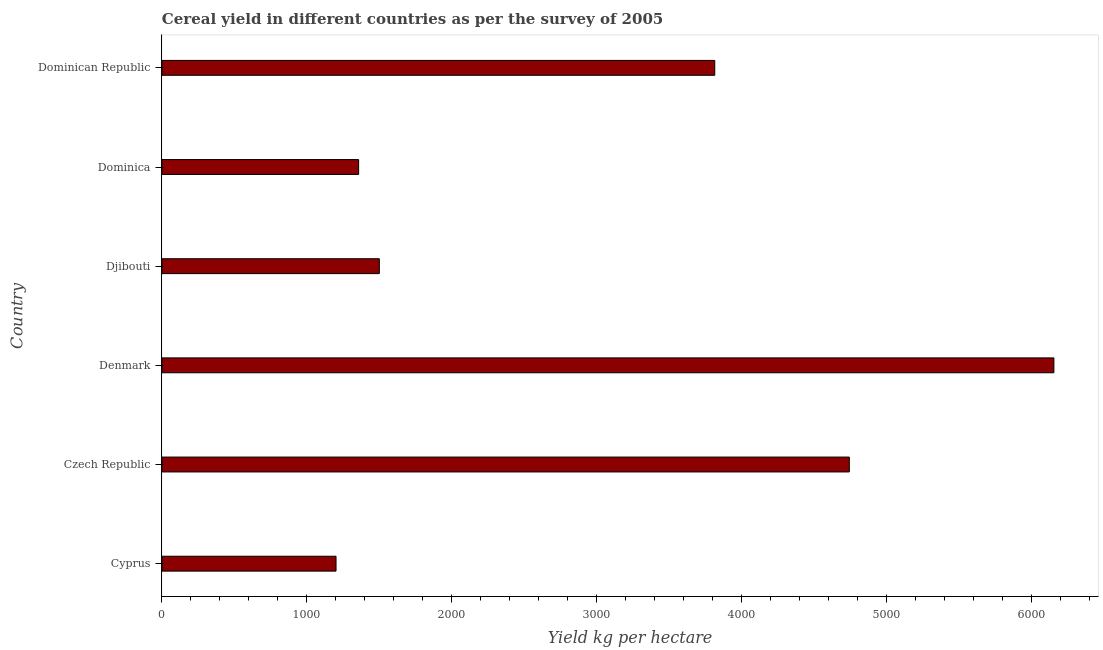Does the graph contain any zero values?
Give a very brief answer. No. Does the graph contain grids?
Provide a succinct answer. No. What is the title of the graph?
Provide a succinct answer. Cereal yield in different countries as per the survey of 2005. What is the label or title of the X-axis?
Keep it short and to the point. Yield kg per hectare. What is the label or title of the Y-axis?
Your answer should be compact. Country. What is the cereal yield in Dominica?
Make the answer very short. 1357.14. Across all countries, what is the maximum cereal yield?
Your answer should be very brief. 6153.39. Across all countries, what is the minimum cereal yield?
Your response must be concise. 1201.23. In which country was the cereal yield minimum?
Ensure brevity in your answer.  Cyprus. What is the sum of the cereal yield?
Your response must be concise. 1.88e+04. What is the difference between the cereal yield in Czech Republic and Djibouti?
Keep it short and to the point. 3242.21. What is the average cereal yield per country?
Keep it short and to the point. 3127.96. What is the median cereal yield?
Give a very brief answer. 2656.89. What is the ratio of the cereal yield in Czech Republic to that in Djibouti?
Give a very brief answer. 3.16. What is the difference between the highest and the second highest cereal yield?
Offer a terse response. 1411.18. What is the difference between the highest and the lowest cereal yield?
Provide a succinct answer. 4952.15. In how many countries, is the cereal yield greater than the average cereal yield taken over all countries?
Provide a short and direct response. 3. What is the difference between two consecutive major ticks on the X-axis?
Your response must be concise. 1000. What is the Yield kg per hectare of Cyprus?
Provide a short and direct response. 1201.23. What is the Yield kg per hectare of Czech Republic?
Offer a terse response. 4742.21. What is the Yield kg per hectare in Denmark?
Your response must be concise. 6153.39. What is the Yield kg per hectare in Djibouti?
Keep it short and to the point. 1500. What is the Yield kg per hectare of Dominica?
Offer a very short reply. 1357.14. What is the Yield kg per hectare of Dominican Republic?
Offer a very short reply. 3813.79. What is the difference between the Yield kg per hectare in Cyprus and Czech Republic?
Provide a short and direct response. -3540.98. What is the difference between the Yield kg per hectare in Cyprus and Denmark?
Your response must be concise. -4952.15. What is the difference between the Yield kg per hectare in Cyprus and Djibouti?
Give a very brief answer. -298.77. What is the difference between the Yield kg per hectare in Cyprus and Dominica?
Ensure brevity in your answer.  -155.91. What is the difference between the Yield kg per hectare in Cyprus and Dominican Republic?
Your answer should be very brief. -2612.56. What is the difference between the Yield kg per hectare in Czech Republic and Denmark?
Give a very brief answer. -1411.18. What is the difference between the Yield kg per hectare in Czech Republic and Djibouti?
Ensure brevity in your answer.  3242.21. What is the difference between the Yield kg per hectare in Czech Republic and Dominica?
Your answer should be very brief. 3385.07. What is the difference between the Yield kg per hectare in Czech Republic and Dominican Republic?
Ensure brevity in your answer.  928.42. What is the difference between the Yield kg per hectare in Denmark and Djibouti?
Your answer should be compact. 4653.39. What is the difference between the Yield kg per hectare in Denmark and Dominica?
Make the answer very short. 4796.24. What is the difference between the Yield kg per hectare in Denmark and Dominican Republic?
Provide a short and direct response. 2339.6. What is the difference between the Yield kg per hectare in Djibouti and Dominica?
Offer a terse response. 142.86. What is the difference between the Yield kg per hectare in Djibouti and Dominican Republic?
Your answer should be compact. -2313.79. What is the difference between the Yield kg per hectare in Dominica and Dominican Republic?
Make the answer very short. -2456.65. What is the ratio of the Yield kg per hectare in Cyprus to that in Czech Republic?
Offer a very short reply. 0.25. What is the ratio of the Yield kg per hectare in Cyprus to that in Denmark?
Offer a terse response. 0.2. What is the ratio of the Yield kg per hectare in Cyprus to that in Djibouti?
Provide a short and direct response. 0.8. What is the ratio of the Yield kg per hectare in Cyprus to that in Dominica?
Keep it short and to the point. 0.89. What is the ratio of the Yield kg per hectare in Cyprus to that in Dominican Republic?
Keep it short and to the point. 0.32. What is the ratio of the Yield kg per hectare in Czech Republic to that in Denmark?
Your answer should be very brief. 0.77. What is the ratio of the Yield kg per hectare in Czech Republic to that in Djibouti?
Make the answer very short. 3.16. What is the ratio of the Yield kg per hectare in Czech Republic to that in Dominica?
Make the answer very short. 3.49. What is the ratio of the Yield kg per hectare in Czech Republic to that in Dominican Republic?
Your response must be concise. 1.24. What is the ratio of the Yield kg per hectare in Denmark to that in Djibouti?
Your response must be concise. 4.1. What is the ratio of the Yield kg per hectare in Denmark to that in Dominica?
Offer a very short reply. 4.53. What is the ratio of the Yield kg per hectare in Denmark to that in Dominican Republic?
Your answer should be compact. 1.61. What is the ratio of the Yield kg per hectare in Djibouti to that in Dominica?
Offer a very short reply. 1.1. What is the ratio of the Yield kg per hectare in Djibouti to that in Dominican Republic?
Give a very brief answer. 0.39. What is the ratio of the Yield kg per hectare in Dominica to that in Dominican Republic?
Your answer should be very brief. 0.36. 